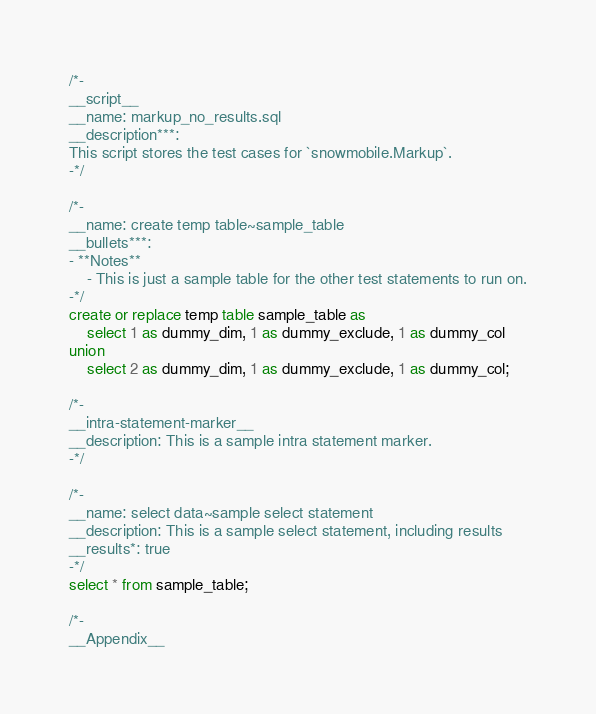<code> <loc_0><loc_0><loc_500><loc_500><_SQL_>
/*-
__script__
__name: markup_no_results.sql
__description***:
This script stores the test cases for `snowmobile.Markup`.
-*/

/*-
__name: create temp table~sample_table
__bullets***:
- **Notes**
	- This is just a sample table for the other test statements to run on.
-*/
create or replace temp table sample_table as
	select 1 as dummy_dim, 1 as dummy_exclude, 1 as dummy_col
union
	select 2 as dummy_dim, 1 as dummy_exclude, 1 as dummy_col;

/*-
__intra-statement-marker__
__description: This is a sample intra statement marker.
-*/

/*-
__name: select data~sample select statement
__description: This is a sample select statement, including results
__results*: true
-*/
select * from sample_table;

/*-
__Appendix__</code> 